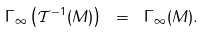Convert formula to latex. <formula><loc_0><loc_0><loc_500><loc_500>\Gamma _ { \infty } \left ( \mathcal { T } ^ { - 1 } ( M ) \right ) \ = \ \Gamma _ { \infty } ( M ) .</formula> 